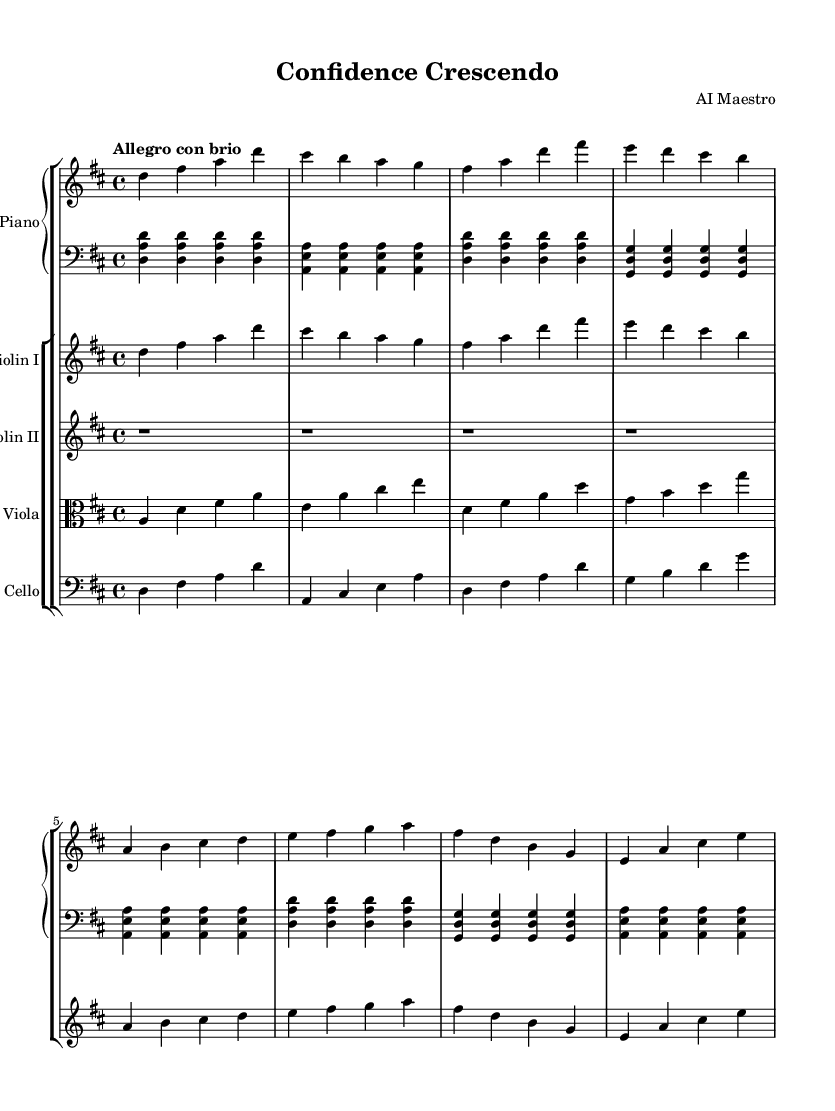What is the key signature of this music? The key signature is D major, which has two sharps (F# and C#). This can be determined by examining the key signature indicated at the beginning of the staff.
Answer: D major What is the time signature of this music? The time signature is 4/4, indicated directly by the fraction shown at the beginning of the score. This means there are four beats in each measure and a quarter note gets one beat.
Answer: 4/4 What is the tempo marking of this piece? The tempo marking is "Allegro con brio." This is typically placed at the beginning of a piece, specifying the mood and pace at which it should be played.
Answer: Allegro con brio How many measures are in the right hand part? The right hand part contains 8 measures, which can be calculated by counting the vertical lines marking the end of each measure in the right hand staff.
Answer: 8 measures Which theme appears first in this composition? The main theme appears first in this composition, as indicated by its placement in the musical score before the secondary theme.
Answer: main theme Identify the first note played by the left hand. The first note played by the left hand is D. This can be found as it is the very first note written in the left hand staff, located at the start of the score.
Answer: D What instruments are included in this ensemble? The instruments included are Piano, Violin I, Violin II, Viola, and Cello. This can be determined by examining the instrumental labels at the beginning of each staff in the score.
Answer: Piano, Violin I, Violin II, Viola, Cello 